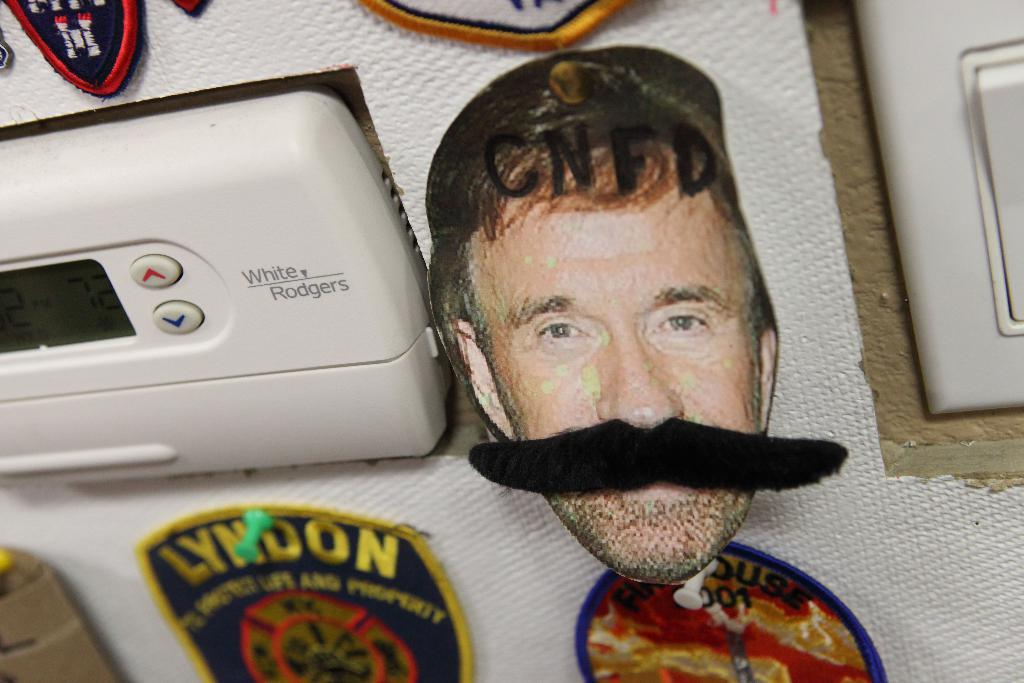<image>
Provide a brief description of the given image. A patch with the words Lyndon in yellow hangs on a wall. 